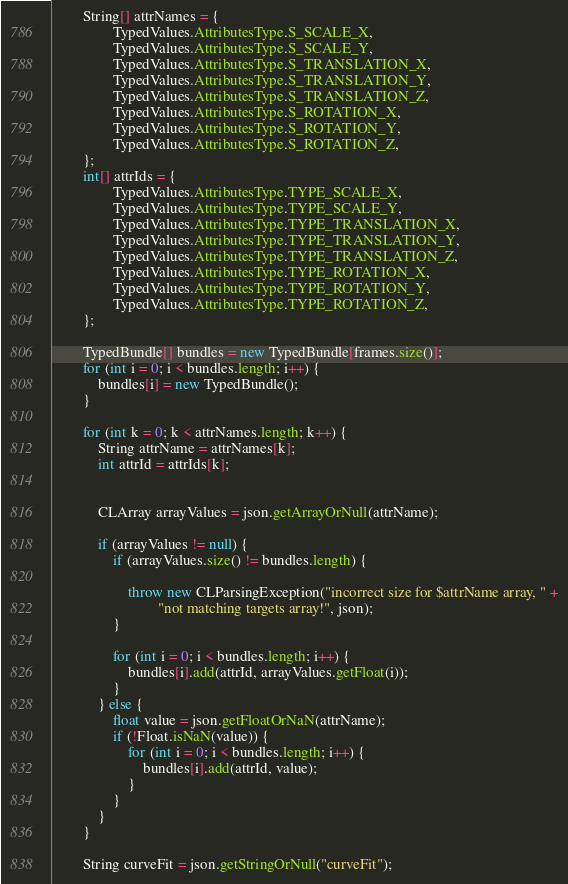<code> <loc_0><loc_0><loc_500><loc_500><_Java_>
        String[] attrNames = {
                TypedValues.AttributesType.S_SCALE_X,
                TypedValues.AttributesType.S_SCALE_Y,
                TypedValues.AttributesType.S_TRANSLATION_X,
                TypedValues.AttributesType.S_TRANSLATION_Y,
                TypedValues.AttributesType.S_TRANSLATION_Z,
                TypedValues.AttributesType.S_ROTATION_X,
                TypedValues.AttributesType.S_ROTATION_Y,
                TypedValues.AttributesType.S_ROTATION_Z,
        };
        int[] attrIds = {
                TypedValues.AttributesType.TYPE_SCALE_X,
                TypedValues.AttributesType.TYPE_SCALE_Y,
                TypedValues.AttributesType.TYPE_TRANSLATION_X,
                TypedValues.AttributesType.TYPE_TRANSLATION_Y,
                TypedValues.AttributesType.TYPE_TRANSLATION_Z,
                TypedValues.AttributesType.TYPE_ROTATION_X,
                TypedValues.AttributesType.TYPE_ROTATION_Y,
                TypedValues.AttributesType.TYPE_ROTATION_Z,
        };

        TypedBundle[] bundles = new TypedBundle[frames.size()];
        for (int i = 0; i < bundles.length; i++) {
            bundles[i] = new TypedBundle();
        }

        for (int k = 0; k < attrNames.length; k++) {
            String attrName = attrNames[k];
            int attrId = attrIds[k];


            CLArray arrayValues = json.getArrayOrNull(attrName);

            if (arrayValues != null) {
                if (arrayValues.size() != bundles.length) {

                    throw new CLParsingException("incorrect size for $attrName array, " +
                            "not matching targets array!", json);
                }

                for (int i = 0; i < bundles.length; i++) {
                    bundles[i].add(attrId, arrayValues.getFloat(i));
                }
            } else {
                float value = json.getFloatOrNaN(attrName);
                if (!Float.isNaN(value)) {
                    for (int i = 0; i < bundles.length; i++) {
                        bundles[i].add(attrId, value);
                    }
                }
            }
        }

        String curveFit = json.getStringOrNull("curveFit");</code> 